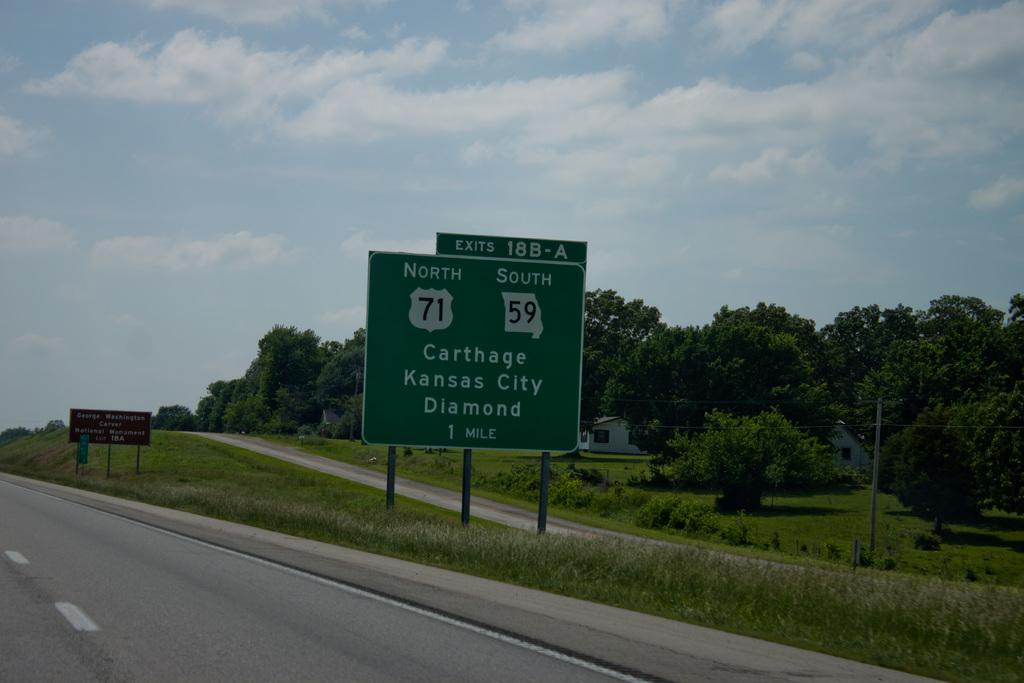Provide a one-sentence caption for the provided image. A highway sign informs travelers that Carthage, Kansas City and Diamond are one mile away. 